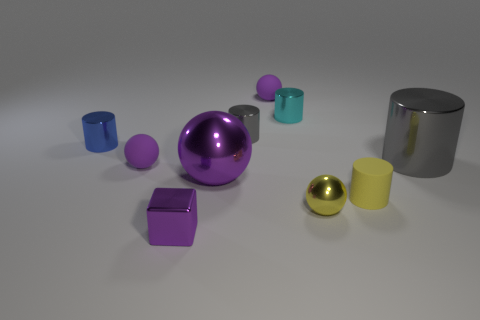Is the material of the tiny sphere to the left of the big purple ball the same as the gray cylinder that is behind the big metal cylinder?
Your response must be concise. No. What number of cylinders have the same size as the metallic block?
Your answer should be compact. 4. The small shiny thing that is the same color as the large sphere is what shape?
Provide a succinct answer. Cube. What material is the tiny cylinder in front of the big purple sphere?
Offer a terse response. Rubber. How many tiny matte objects are the same shape as the big purple metallic thing?
Offer a very short reply. 2. The tiny cyan thing that is the same material as the yellow ball is what shape?
Make the answer very short. Cylinder. What shape is the gray thing that is left of the small purple ball behind the gray metal object that is left of the yellow matte cylinder?
Your answer should be very brief. Cylinder. Is the number of big purple cylinders greater than the number of gray shiny things?
Make the answer very short. No. What material is the large purple thing that is the same shape as the small yellow shiny object?
Keep it short and to the point. Metal. Does the blue thing have the same material as the large gray thing?
Keep it short and to the point. Yes. 